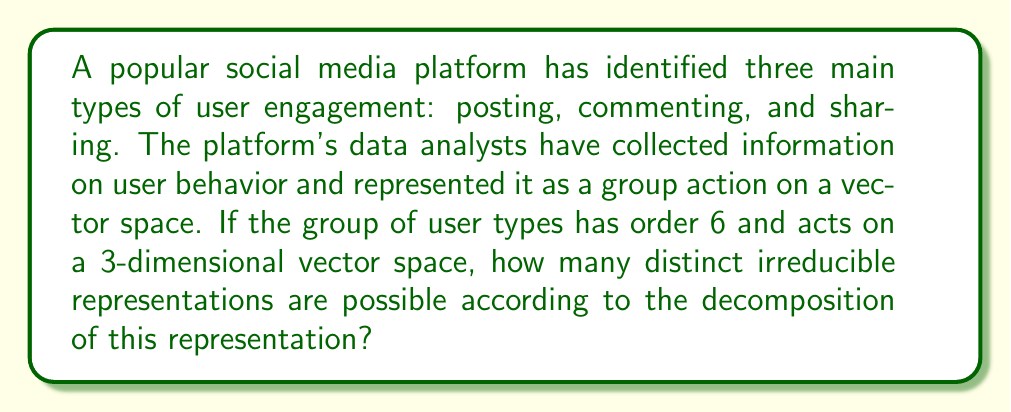What is the answer to this math problem? To solve this problem, we'll follow these steps:

1) First, recall that for a finite group $G$ acting on a finite-dimensional vector space $V$, the number of distinct irreducible representations is equal to the number of conjugacy classes of $G$.

2) The group of user types has order 6. The possible groups of order 6 are the cyclic group $C_6$ and the dihedral group $D_3$ (also known as $S_3$, the symmetric group on 3 elements).

3) For $C_6$, each element forms its own conjugacy class, so there would be 6 irreducible representations.

4) For $D_3$ (or $S_3$), there are 3 conjugacy classes:
   - The identity element
   - The 3 transpositions
   - The 2 3-cycles

5) Given the context of user engagement types (posting, commenting, sharing), $D_3$ (or $S_3$) is more likely to represent the group structure, as it allows for permutations of these three actions.

6) Therefore, the number of distinct irreducible representations is equal to the number of conjugacy classes in $D_3$, which is 3.

This answer aligns with the character table of $S_3$, which has three irreducible representations: the trivial representation, the sign representation, and a 2-dimensional representation.
Answer: 3 